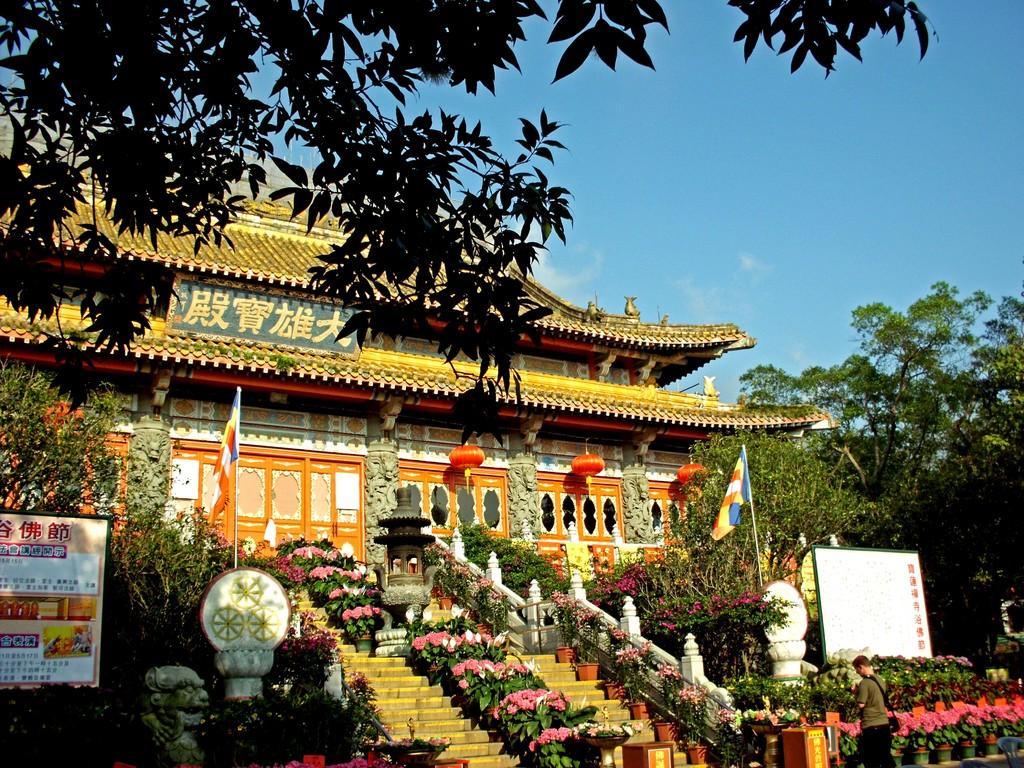Describe this image in one or two sentences. In the image there is a temple in the front with many plants and trees in front of it and a person standing on the right side and above its sky. 